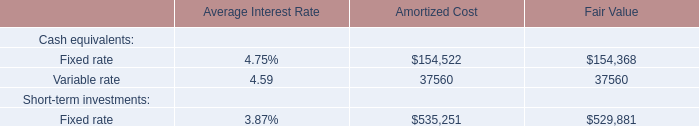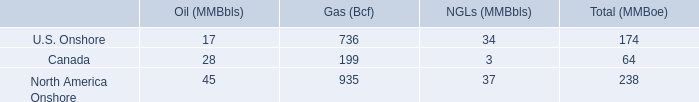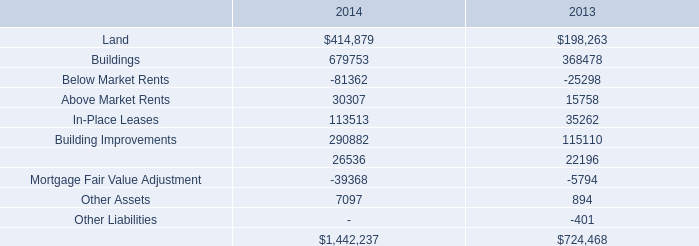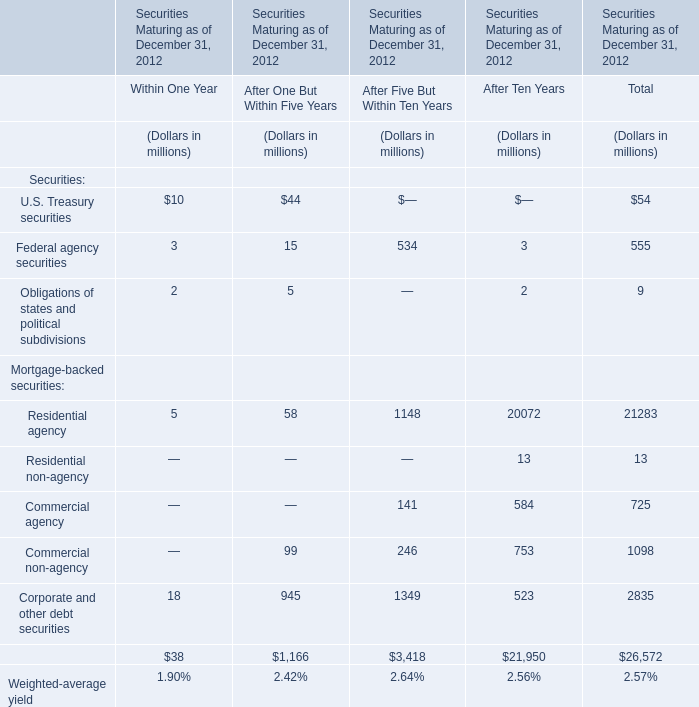What was the total amount of Residential agency, Residential non-agency, Commercial agency and Commercial non-agency in for After Ten Years? (in million) 
Computations: (((20072 + 13) + 584) + 753)
Answer: 21422.0. 